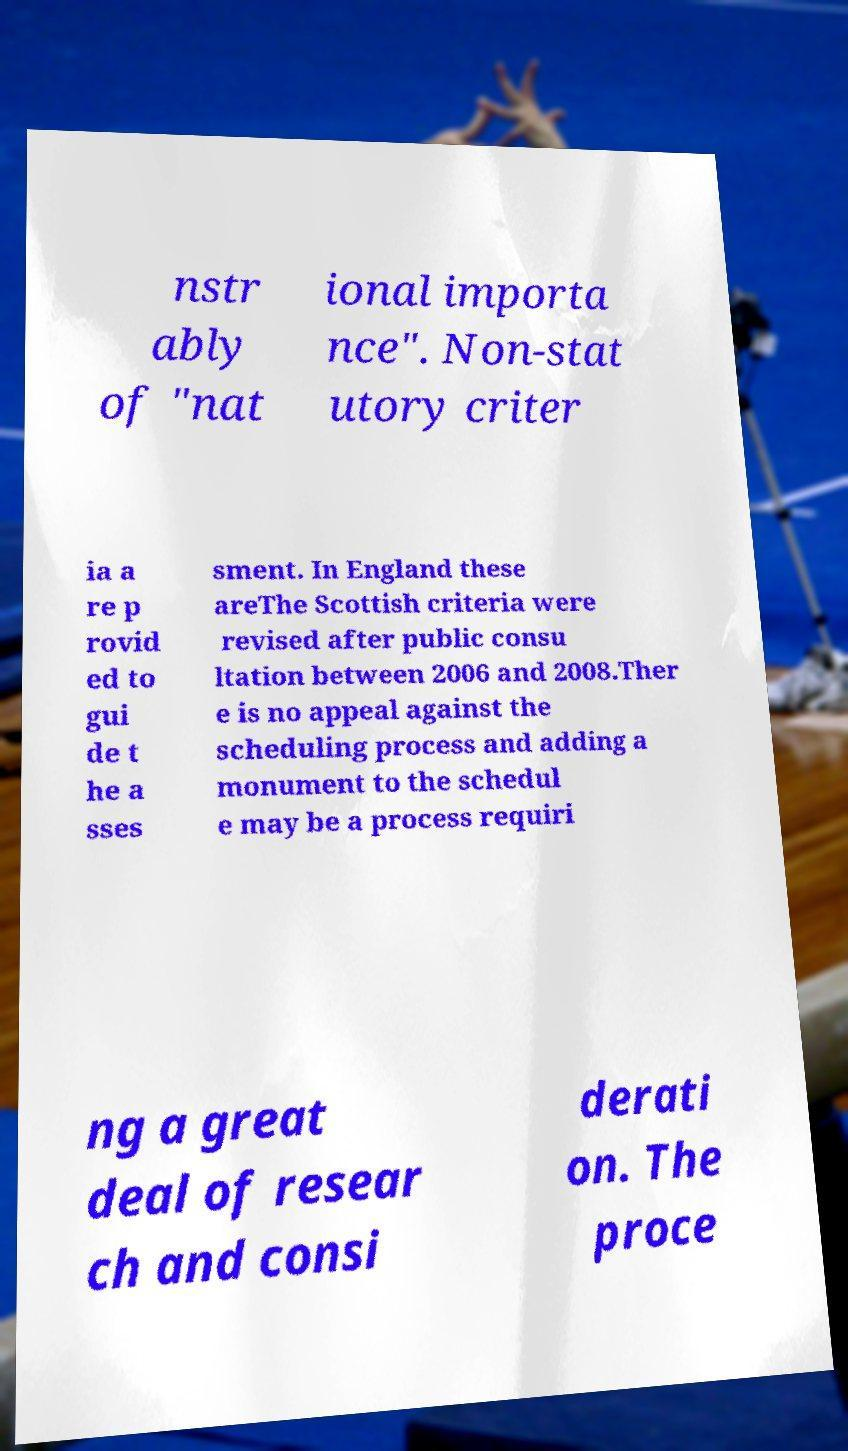What messages or text are displayed in this image? I need them in a readable, typed format. nstr ably of "nat ional importa nce". Non-stat utory criter ia a re p rovid ed to gui de t he a sses sment. In England these areThe Scottish criteria were revised after public consu ltation between 2006 and 2008.Ther e is no appeal against the scheduling process and adding a monument to the schedul e may be a process requiri ng a great deal of resear ch and consi derati on. The proce 